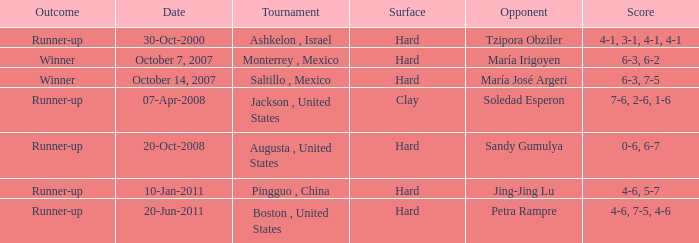What was the outcome when Jing-Jing Lu was the opponent? Runner-up. 